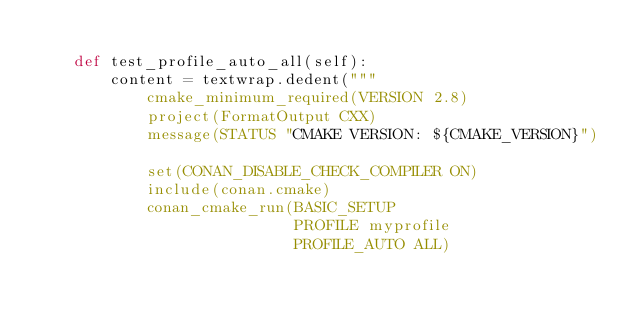Convert code to text. <code><loc_0><loc_0><loc_500><loc_500><_Python_>
    def test_profile_auto_all(self):
        content = textwrap.dedent("""
            cmake_minimum_required(VERSION 2.8)
            project(FormatOutput CXX)
            message(STATUS "CMAKE VERSION: ${CMAKE_VERSION}")

            set(CONAN_DISABLE_CHECK_COMPILER ON)
            include(conan.cmake)
            conan_cmake_run(BASIC_SETUP
                            PROFILE myprofile
                            PROFILE_AUTO ALL)
</code> 